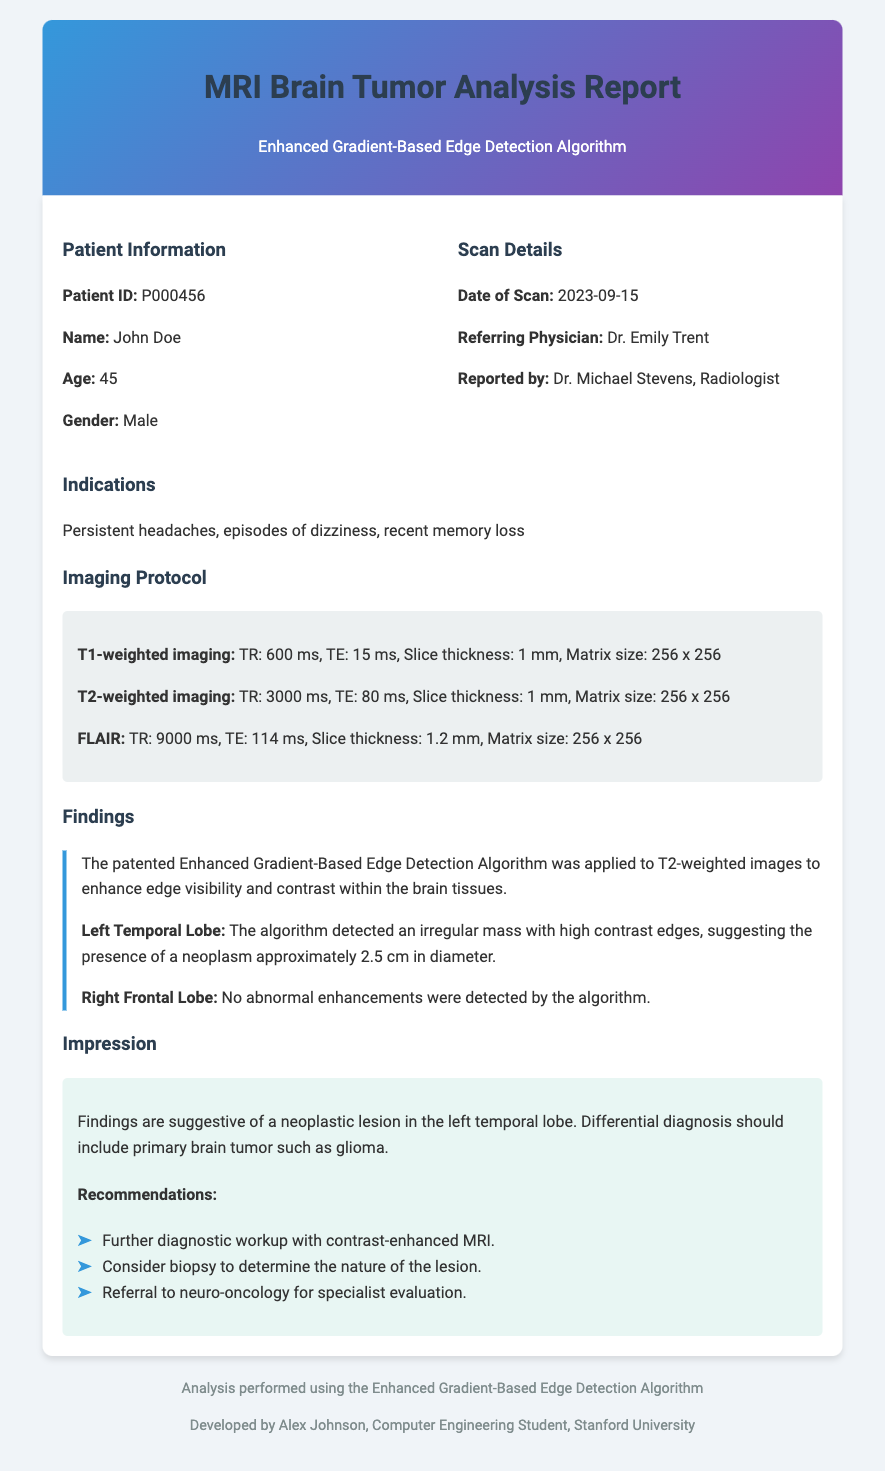What is the patient ID? The patient ID is specified in the patient information section of the document.
Answer: P000456 What was the date of the scan? The date of the scan is listed under the scan details section.
Answer: 2023-09-15 What symptoms did the patient present? The indications section details the symptoms the patient experienced.
Answer: Persistent headaches, episodes of dizziness, recent memory loss What irregular mass was detected? The findings section describes the abnormality found in the left temporal lobe.
Answer: A neoplasm approximately 2.5 cm in diameter Which lobes were examined by the algorithm? The findings section specifies the areas that were evaluated by the algorithm.
Answer: Left Temporal Lobe and Right Frontal Lobe What is one recommendation from the impression? The recommendations are provided under the impression section of the document.
Answer: Further diagnostic workup with contrast-enhanced MRI Who reported the MRI results? The referring physician's name is stated in the scan details section.
Answer: Dr. Michael Stevens What imaging technique was specifically mentioned for enhancing edge visibility? The document indicates the specific algorithm used in the analysis of the scans.
Answer: Enhanced Gradient-Based Edge Detection Algorithm 